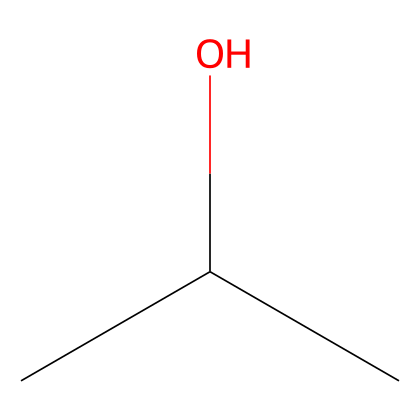How many carbon atoms are in this compound? The SMILES representation indicates 'CC(C)', which shows there are three 'C' characters, meaning there are three carbon atoms.
Answer: three What is the main functional group present in this compound? The 'O' in the SMILES indicates the presence of a hydroxyl group (–OH), designating this compound as an alcohol.
Answer: alcohol What is the total number of hydrogen atoms in this compound? Each carbon typically bonds with enough hydrogen atoms to fulfill its tetravalent nature. Given the structure, the compound has three carbon atoms bonded in a branched formation, leading to a total of 8 hydrogen atoms.
Answer: eight Is this compound classified as a saturated or unsaturated hydrocarbon? Since the compound has only single bonds between carbon and does not contain double or triple bonds, it is classified as a saturated hydrocarbon.
Answer: saturated What type of compound is this based on its carbon structure? The presence of carbon atoms in a linear and branched arrangement indicates that this is an aliphatic compound, as it fits the definition of not being aromatic.
Answer: aliphatic What can be inferred about the solubility of this compound in water? The presence of the hydroxyl group (–OH) increases its polarity, suggesting it is likely to be soluble in water, a characteristic common to alcohols.
Answer: soluble 